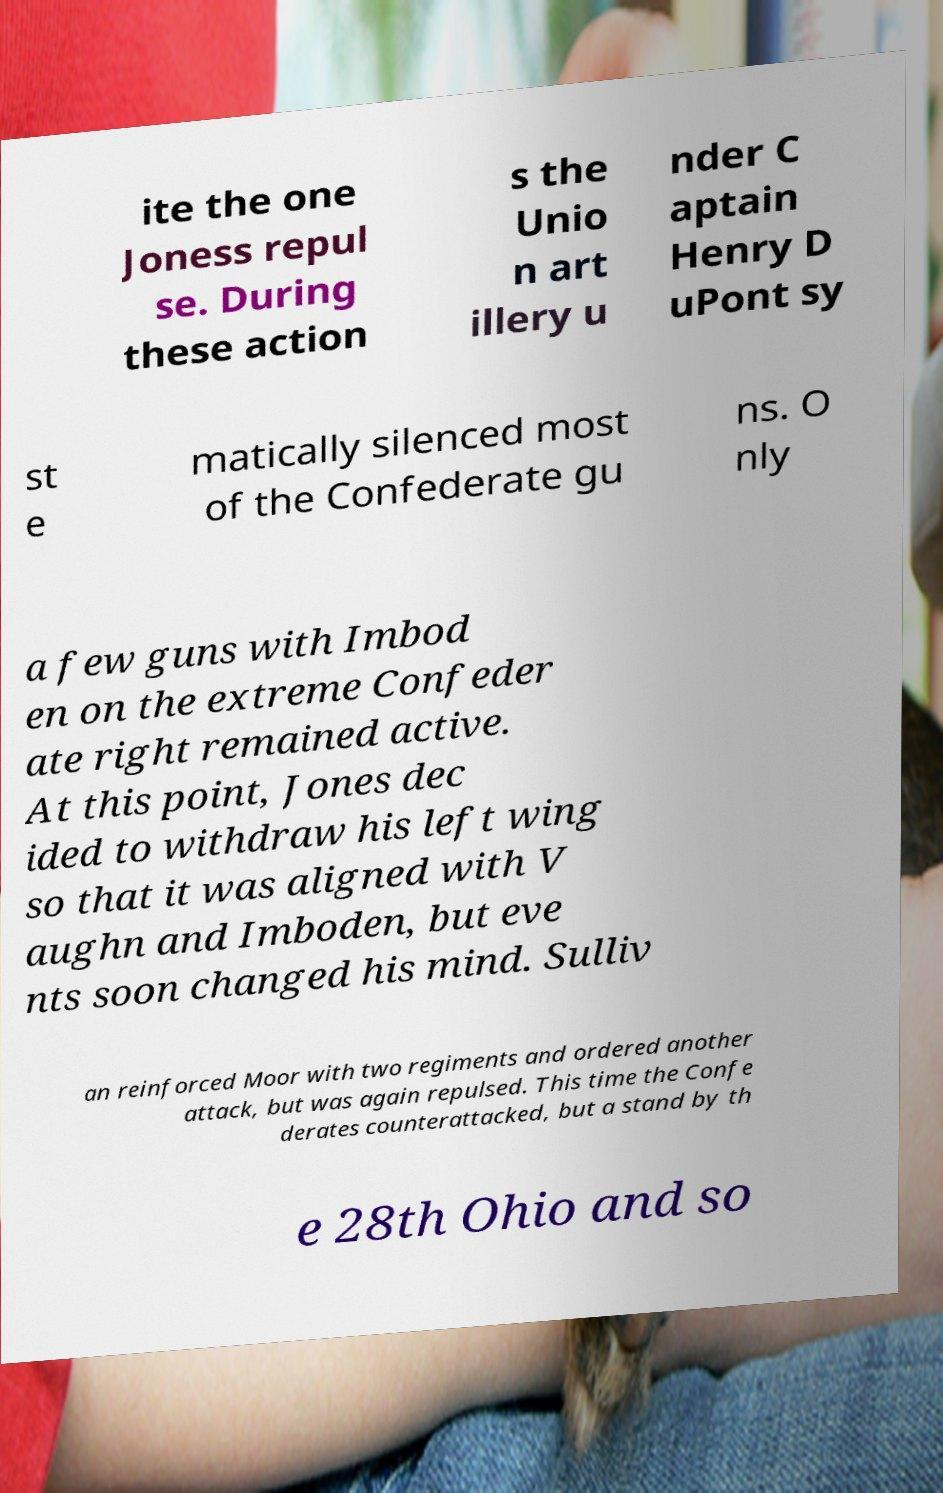Could you extract and type out the text from this image? ite the one Joness repul se. During these action s the Unio n art illery u nder C aptain Henry D uPont sy st e matically silenced most of the Confederate gu ns. O nly a few guns with Imbod en on the extreme Confeder ate right remained active. At this point, Jones dec ided to withdraw his left wing so that it was aligned with V aughn and Imboden, but eve nts soon changed his mind. Sulliv an reinforced Moor with two regiments and ordered another attack, but was again repulsed. This time the Confe derates counterattacked, but a stand by th e 28th Ohio and so 